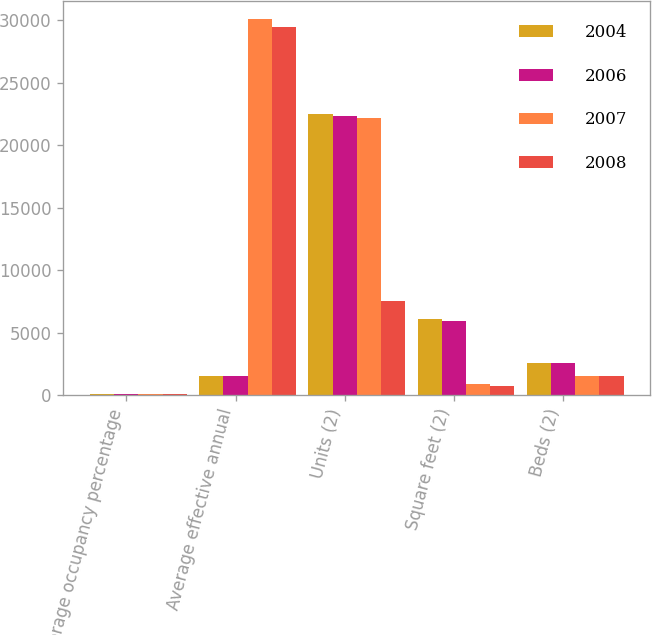<chart> <loc_0><loc_0><loc_500><loc_500><stacked_bar_chart><ecel><fcel>Average occupancy percentage<fcel>Average effective annual<fcel>Units (2)<fcel>Square feet (2)<fcel>Beds (2)<nl><fcel>2004<fcel>91<fcel>1568<fcel>22458<fcel>6126<fcel>2562<nl><fcel>2006<fcel>83<fcel>1568<fcel>22357<fcel>5896<fcel>2562<nl><fcel>2007<fcel>98<fcel>30063<fcel>22142<fcel>897<fcel>1568<nl><fcel>2008<fcel>100<fcel>29420<fcel>7528<fcel>738<fcel>1568<nl></chart> 